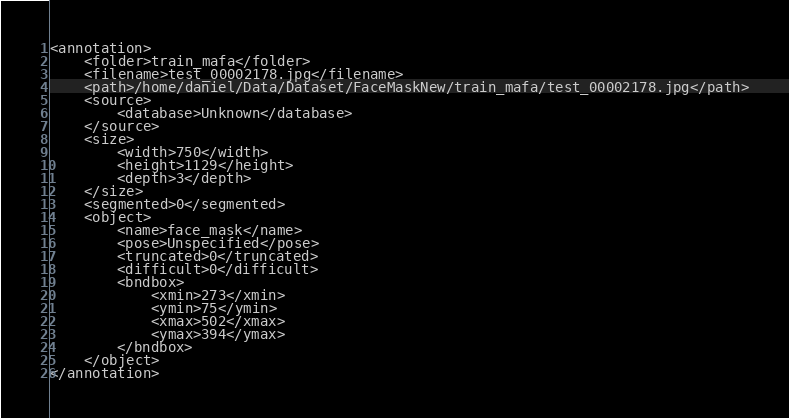<code> <loc_0><loc_0><loc_500><loc_500><_XML_><annotation>
	<folder>train_mafa</folder>
	<filename>test_00002178.jpg</filename>
	<path>/home/daniel/Data/Dataset/FaceMaskNew/train_mafa/test_00002178.jpg</path>
	<source>
		<database>Unknown</database>
	</source>
	<size>
		<width>750</width>
		<height>1129</height>
		<depth>3</depth>
	</size>
	<segmented>0</segmented>
	<object>
		<name>face_mask</name>
		<pose>Unspecified</pose>
		<truncated>0</truncated>
		<difficult>0</difficult>
		<bndbox>
			<xmin>273</xmin>
			<ymin>75</ymin>
			<xmax>502</xmax>
			<ymax>394</ymax>
		</bndbox>
	</object>
</annotation>
</code> 